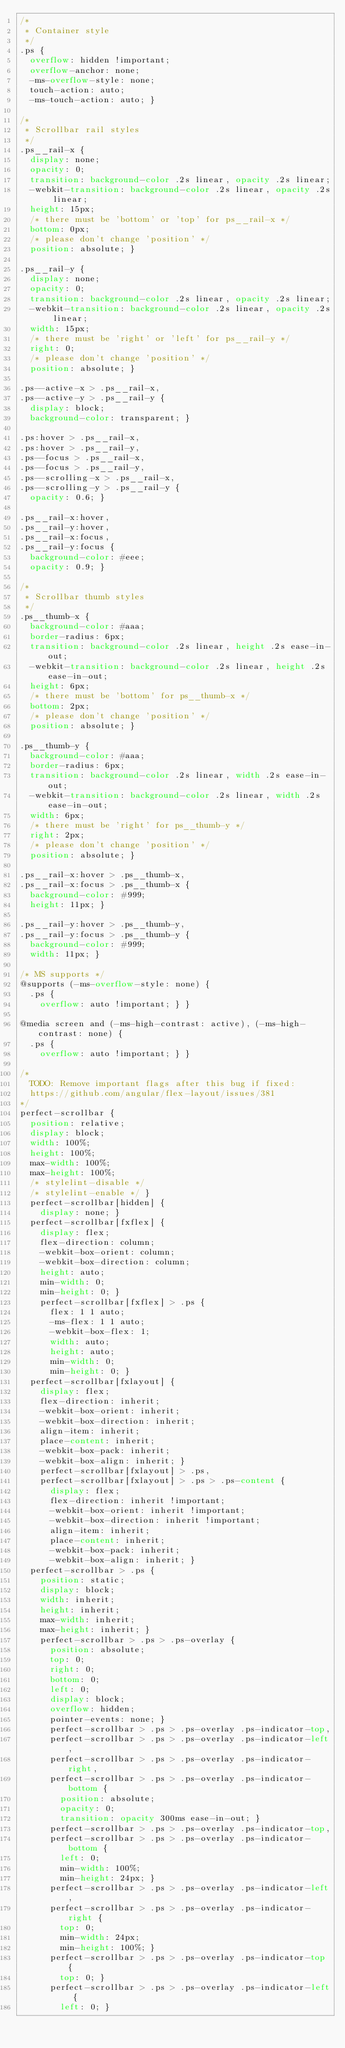<code> <loc_0><loc_0><loc_500><loc_500><_CSS_>/*
 * Container style
 */
.ps {
  overflow: hidden !important;
  overflow-anchor: none;
  -ms-overflow-style: none;
  touch-action: auto;
  -ms-touch-action: auto; }

/*
 * Scrollbar rail styles
 */
.ps__rail-x {
  display: none;
  opacity: 0;
  transition: background-color .2s linear, opacity .2s linear;
  -webkit-transition: background-color .2s linear, opacity .2s linear;
  height: 15px;
  /* there must be 'bottom' or 'top' for ps__rail-x */
  bottom: 0px;
  /* please don't change 'position' */
  position: absolute; }

.ps__rail-y {
  display: none;
  opacity: 0;
  transition: background-color .2s linear, opacity .2s linear;
  -webkit-transition: background-color .2s linear, opacity .2s linear;
  width: 15px;
  /* there must be 'right' or 'left' for ps__rail-y */
  right: 0;
  /* please don't change 'position' */
  position: absolute; }

.ps--active-x > .ps__rail-x,
.ps--active-y > .ps__rail-y {
  display: block;
  background-color: transparent; }

.ps:hover > .ps__rail-x,
.ps:hover > .ps__rail-y,
.ps--focus > .ps__rail-x,
.ps--focus > .ps__rail-y,
.ps--scrolling-x > .ps__rail-x,
.ps--scrolling-y > .ps__rail-y {
  opacity: 0.6; }

.ps__rail-x:hover,
.ps__rail-y:hover,
.ps__rail-x:focus,
.ps__rail-y:focus {
  background-color: #eee;
  opacity: 0.9; }

/*
 * Scrollbar thumb styles
 */
.ps__thumb-x {
  background-color: #aaa;
  border-radius: 6px;
  transition: background-color .2s linear, height .2s ease-in-out;
  -webkit-transition: background-color .2s linear, height .2s ease-in-out;
  height: 6px;
  /* there must be 'bottom' for ps__thumb-x */
  bottom: 2px;
  /* please don't change 'position' */
  position: absolute; }

.ps__thumb-y {
  background-color: #aaa;
  border-radius: 6px;
  transition: background-color .2s linear, width .2s ease-in-out;
  -webkit-transition: background-color .2s linear, width .2s ease-in-out;
  width: 6px;
  /* there must be 'right' for ps__thumb-y */
  right: 2px;
  /* please don't change 'position' */
  position: absolute; }

.ps__rail-x:hover > .ps__thumb-x,
.ps__rail-x:focus > .ps__thumb-x {
  background-color: #999;
  height: 11px; }

.ps__rail-y:hover > .ps__thumb-y,
.ps__rail-y:focus > .ps__thumb-y {
  background-color: #999;
  width: 11px; }

/* MS supports */
@supports (-ms-overflow-style: none) {
  .ps {
    overflow: auto !important; } }

@media screen and (-ms-high-contrast: active), (-ms-high-contrast: none) {
  .ps {
    overflow: auto !important; } }

/*
  TODO: Remove important flags after this bug if fixed:
  https://github.com/angular/flex-layout/issues/381
*/
perfect-scrollbar {
  position: relative;
  display: block;
  width: 100%;
  height: 100%;
  max-width: 100%;
  max-height: 100%;
  /* stylelint-disable */
  /* stylelint-enable */ }
  perfect-scrollbar[hidden] {
    display: none; }
  perfect-scrollbar[fxflex] {
    display: flex;
    flex-direction: column;
    -webkit-box-orient: column;
    -webkit-box-direction: column;
    height: auto;
    min-width: 0;
    min-height: 0; }
    perfect-scrollbar[fxflex] > .ps {
      flex: 1 1 auto;
      -ms-flex: 1 1 auto;
      -webkit-box-flex: 1;
      width: auto;
      height: auto;
      min-width: 0;
      min-height: 0; }
  perfect-scrollbar[fxlayout] {
    display: flex;
    flex-direction: inherit;
    -webkit-box-orient: inherit;
    -webkit-box-direction: inherit;
    align-item: inherit;
    place-content: inherit;
    -webkit-box-pack: inherit;
    -webkit-box-align: inherit; }
    perfect-scrollbar[fxlayout] > .ps,
    perfect-scrollbar[fxlayout] > .ps > .ps-content {
      display: flex;
      flex-direction: inherit !important;
      -webkit-box-orient: inherit !important;
      -webkit-box-direction: inherit !important;
      align-item: inherit;
      place-content: inherit;
      -webkit-box-pack: inherit;
      -webkit-box-align: inherit; }
  perfect-scrollbar > .ps {
    position: static;
    display: block;
    width: inherit;
    height: inherit;
    max-width: inherit;
    max-height: inherit; }
    perfect-scrollbar > .ps > .ps-overlay {
      position: absolute;
      top: 0;
      right: 0;
      bottom: 0;
      left: 0;
      display: block;
      overflow: hidden;
      pointer-events: none; }
      perfect-scrollbar > .ps > .ps-overlay .ps-indicator-top,
      perfect-scrollbar > .ps > .ps-overlay .ps-indicator-left,
      perfect-scrollbar > .ps > .ps-overlay .ps-indicator-right,
      perfect-scrollbar > .ps > .ps-overlay .ps-indicator-bottom {
        position: absolute;
        opacity: 0;
        transition: opacity 300ms ease-in-out; }
      perfect-scrollbar > .ps > .ps-overlay .ps-indicator-top,
      perfect-scrollbar > .ps > .ps-overlay .ps-indicator-bottom {
        left: 0;
        min-width: 100%;
        min-height: 24px; }
      perfect-scrollbar > .ps > .ps-overlay .ps-indicator-left,
      perfect-scrollbar > .ps > .ps-overlay .ps-indicator-right {
        top: 0;
        min-width: 24px;
        min-height: 100%; }
      perfect-scrollbar > .ps > .ps-overlay .ps-indicator-top {
        top: 0; }
      perfect-scrollbar > .ps > .ps-overlay .ps-indicator-left {
        left: 0; }</code> 